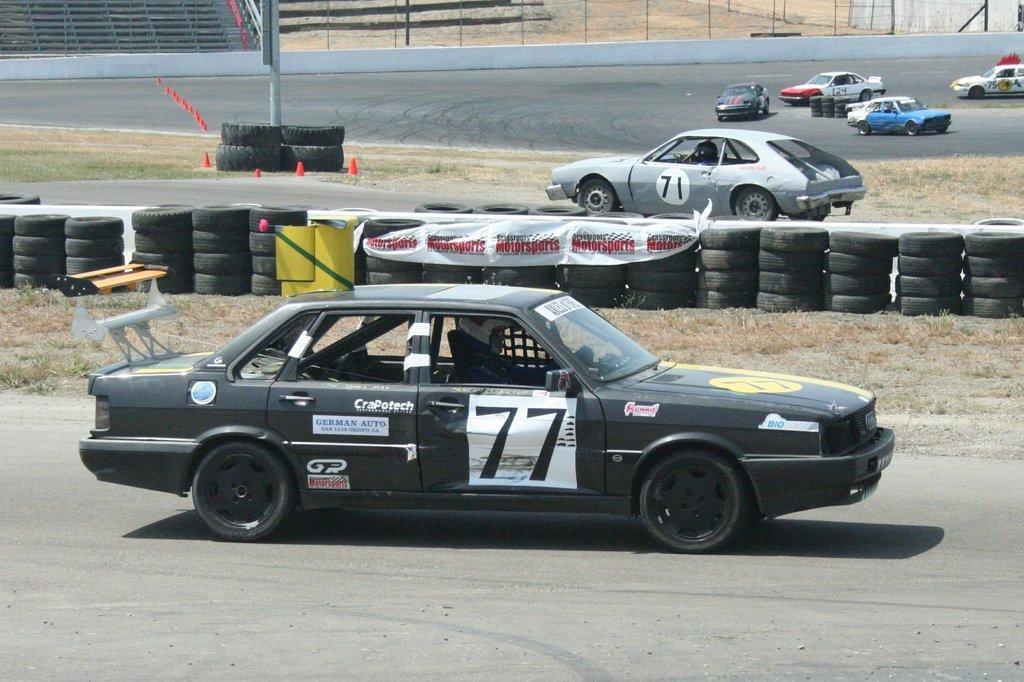Please provide a concise description of this image. In this picture we can observe a black color car moving on the road. There are some tires placed here. In the background there are some cars moving on this road. We can observe a pole in the left side. In the background there is a fence. 